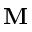Convert formula to latex. <formula><loc_0><loc_0><loc_500><loc_500>M</formula> 